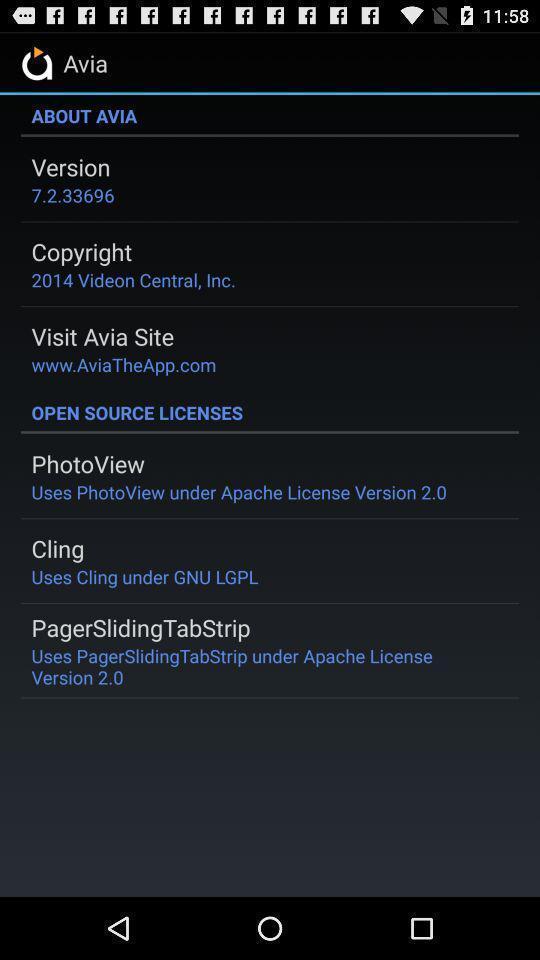Provide a detailed account of this screenshot. Screen displaying app details and licenses. 